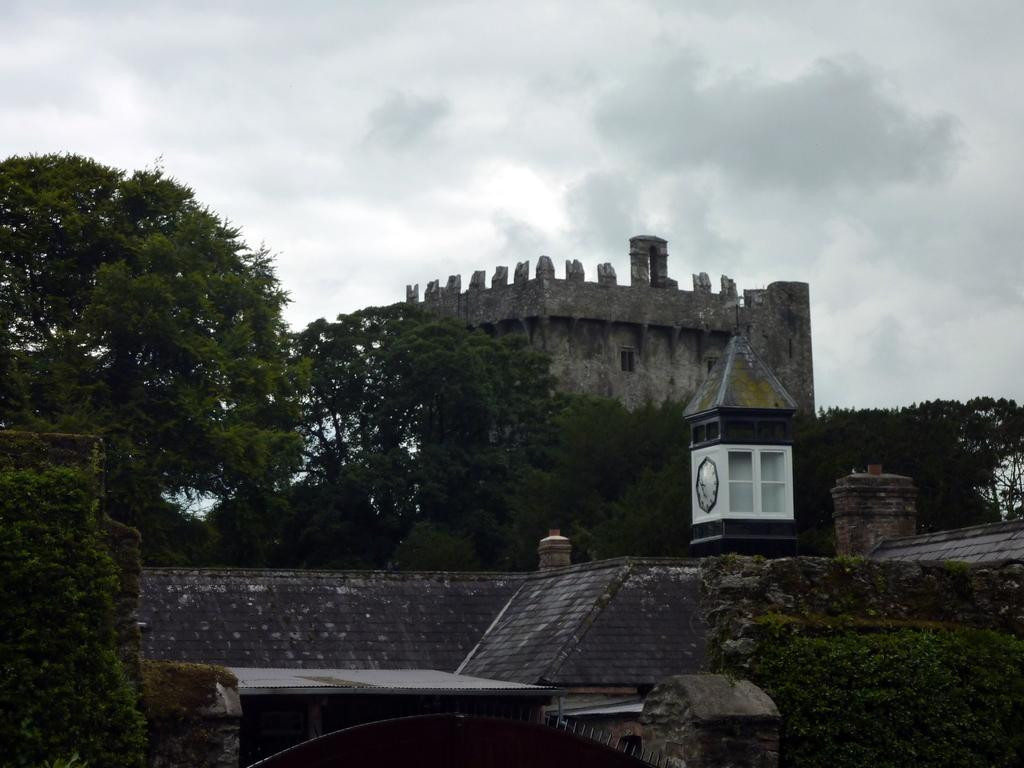What type of vegetation can be seen in the image? There are trees in the image. What is the color of the trees? The trees are green in color. What structures are present in the image? There are buildings in the image. Can you describe the clock in the image? The clock is white in color and is attached to a building. What is visible in the background of the image? The sky is visible in the background of the image. What grade does the clock receive for its performance in the image? There is no grade given to the clock in the image, as it is not a subject that can be evaluated in that manner. What type of yarn is being used to create the trees in the image? There is no yarn present in the image; the trees are depicted as natural vegetation. 